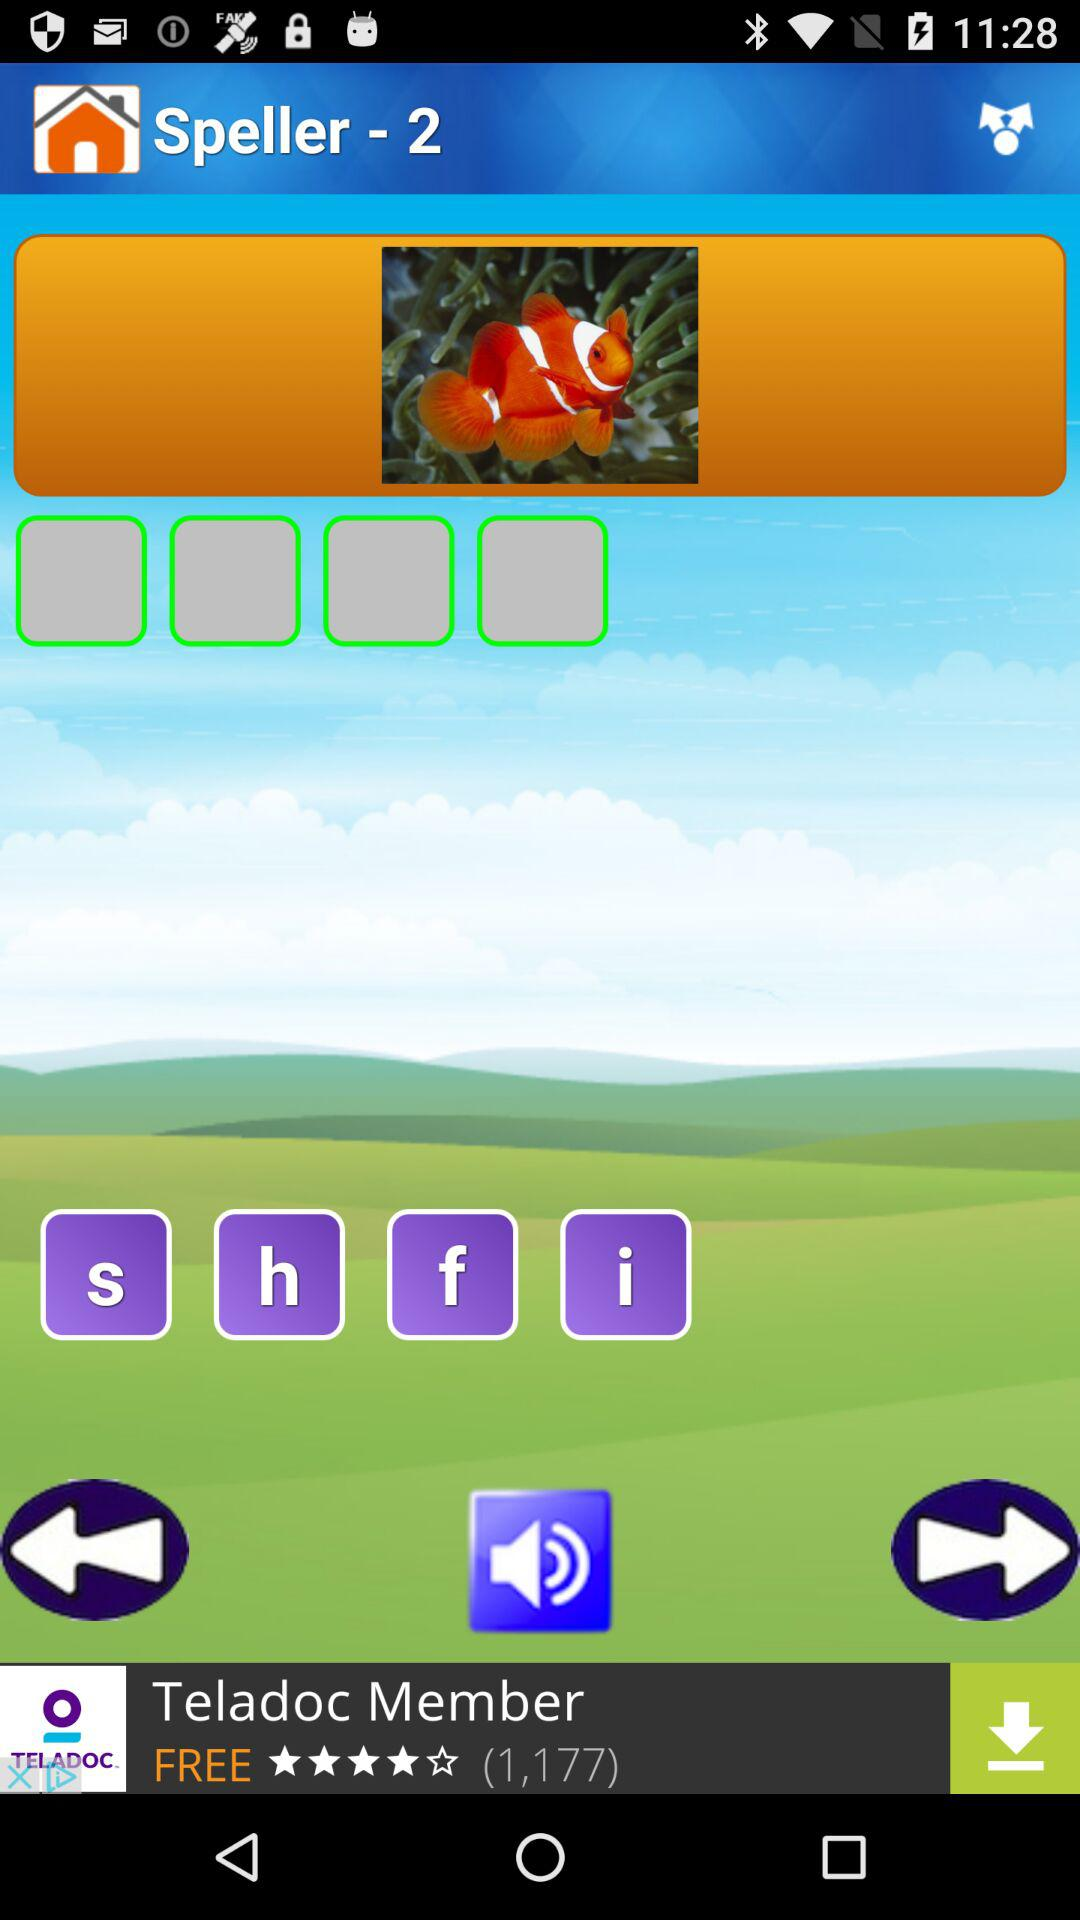What is the application name? The application name is Speller-2. 